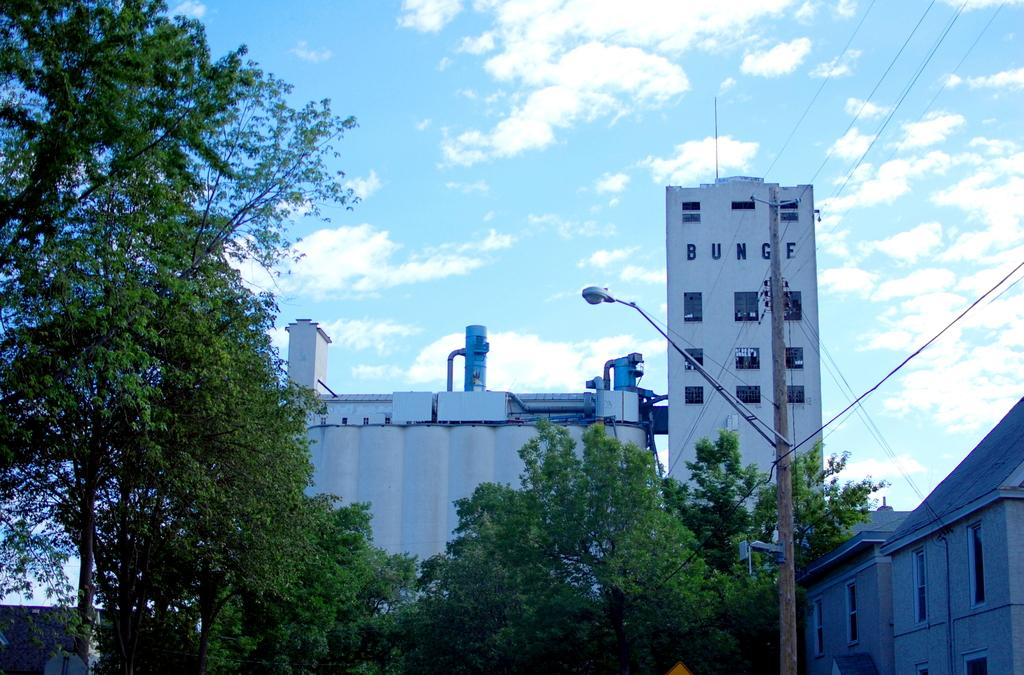What type of structures can be seen in the image? There are buildings in the image. What natural elements are present in the image? There are trees in the image. What type of lighting is visible in the image? There are street lights in the image. Can you describe the fog in the image? There is no fog present in the image. What type of cub is visible in the image? There is no cub present in the image. 